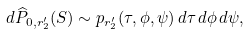<formula> <loc_0><loc_0><loc_500><loc_500>d \widehat { P } _ { 0 , r _ { 2 } ^ { \prime } } ( S ) \sim p _ { r _ { 2 } ^ { \prime } } ( \tau , \phi , \psi ) \, d \tau \, d \phi \, d \psi ,</formula> 